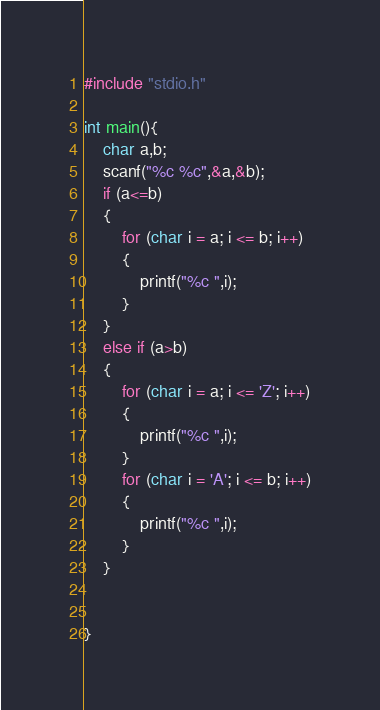Convert code to text. <code><loc_0><loc_0><loc_500><loc_500><_C_>#include "stdio.h"

int main(){
    char a,b;
    scanf("%c %c",&a,&b);
    if (a<=b)
    {
        for (char i = a; i <= b; i++)
        {
            printf("%c ",i);
        }
    }
    else if (a>b)
    {
        for (char i = a; i <= 'Z'; i++)
        {
            printf("%c ",i);
        }
        for (char i = 'A'; i <= b; i++)
        {
            printf("%c ",i);
        }        
    }
    
    
}</code> 